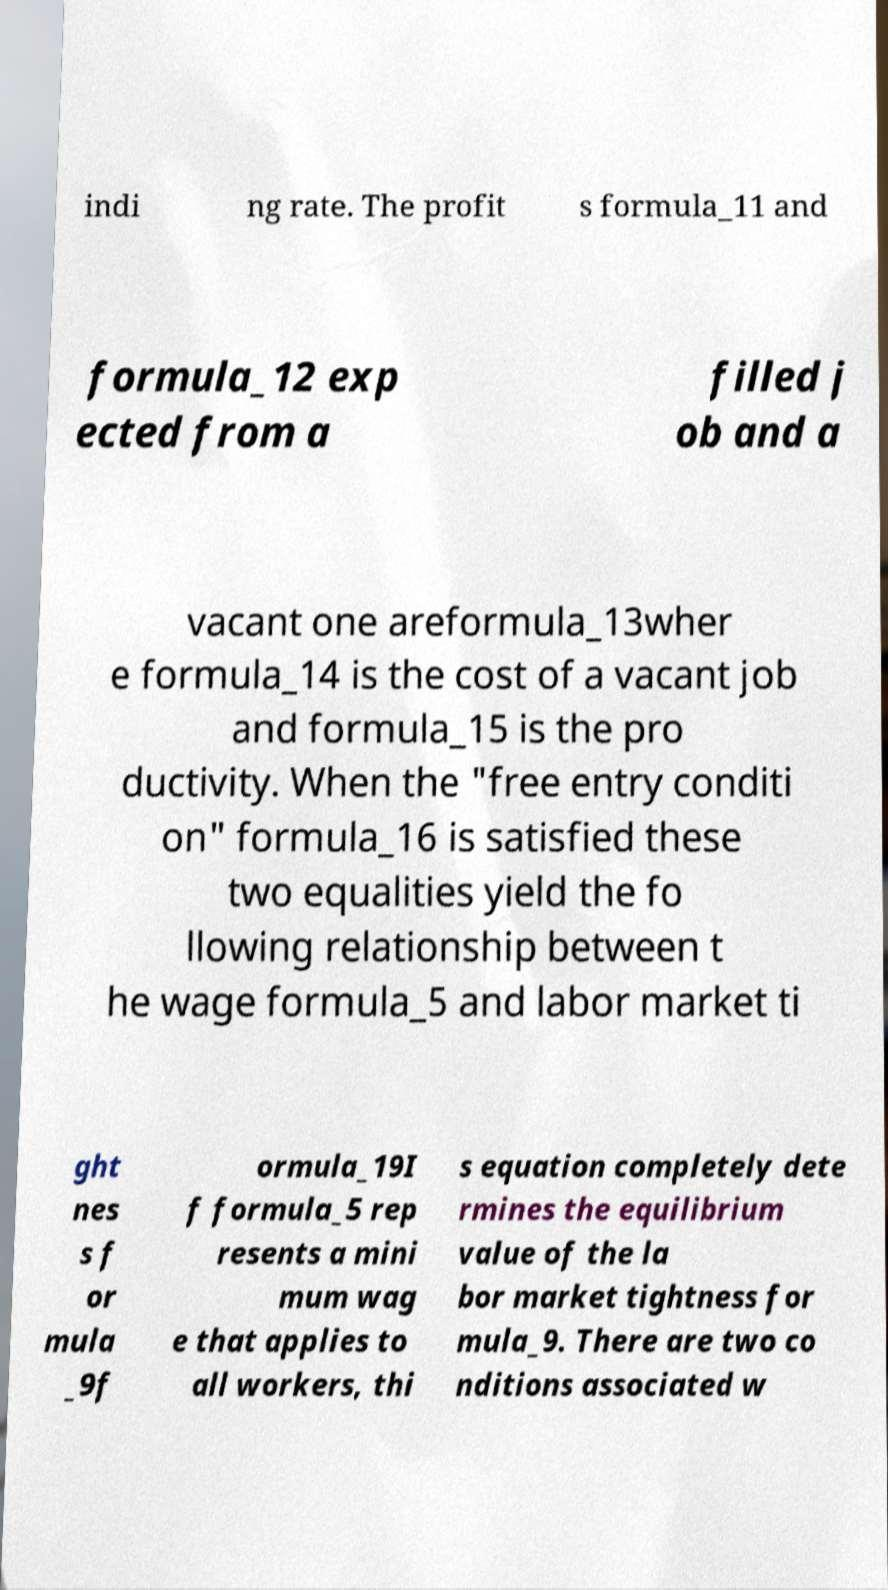Could you assist in decoding the text presented in this image and type it out clearly? indi ng rate. The profit s formula_11 and formula_12 exp ected from a filled j ob and a vacant one areformula_13wher e formula_14 is the cost of a vacant job and formula_15 is the pro ductivity. When the "free entry conditi on" formula_16 is satisfied these two equalities yield the fo llowing relationship between t he wage formula_5 and labor market ti ght nes s f or mula _9f ormula_19I f formula_5 rep resents a mini mum wag e that applies to all workers, thi s equation completely dete rmines the equilibrium value of the la bor market tightness for mula_9. There are two co nditions associated w 